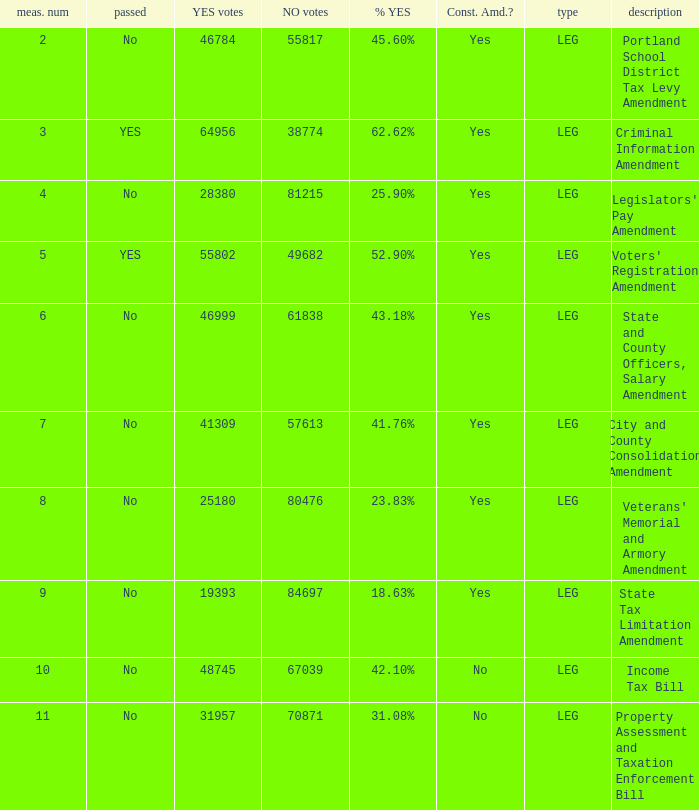HOw many no votes were there when there were 45.60% yes votes 55817.0. 